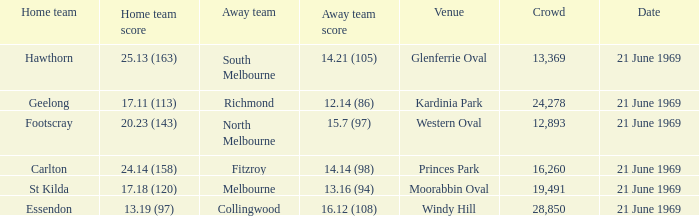In regards to essendon's home team, which one experiences an away crowd size larger than 19,491? Collingwood. 